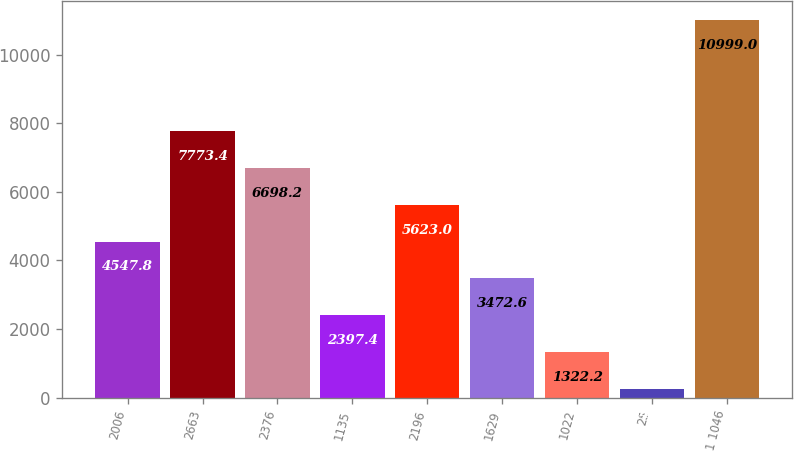<chart> <loc_0><loc_0><loc_500><loc_500><bar_chart><fcel>2006<fcel>2663<fcel>2376<fcel>1135<fcel>2196<fcel>1629<fcel>1022<fcel>25<fcel>1 1046<nl><fcel>4547.8<fcel>7773.4<fcel>6698.2<fcel>2397.4<fcel>5623<fcel>3472.6<fcel>1322.2<fcel>247<fcel>10999<nl></chart> 